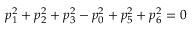<formula> <loc_0><loc_0><loc_500><loc_500>p _ { 1 } ^ { 2 } + p _ { 2 } ^ { 2 } + p _ { 3 } ^ { 2 } - p _ { 0 } ^ { 2 } + p _ { 5 } ^ { 2 } + p _ { 6 } ^ { 2 } = 0</formula> 